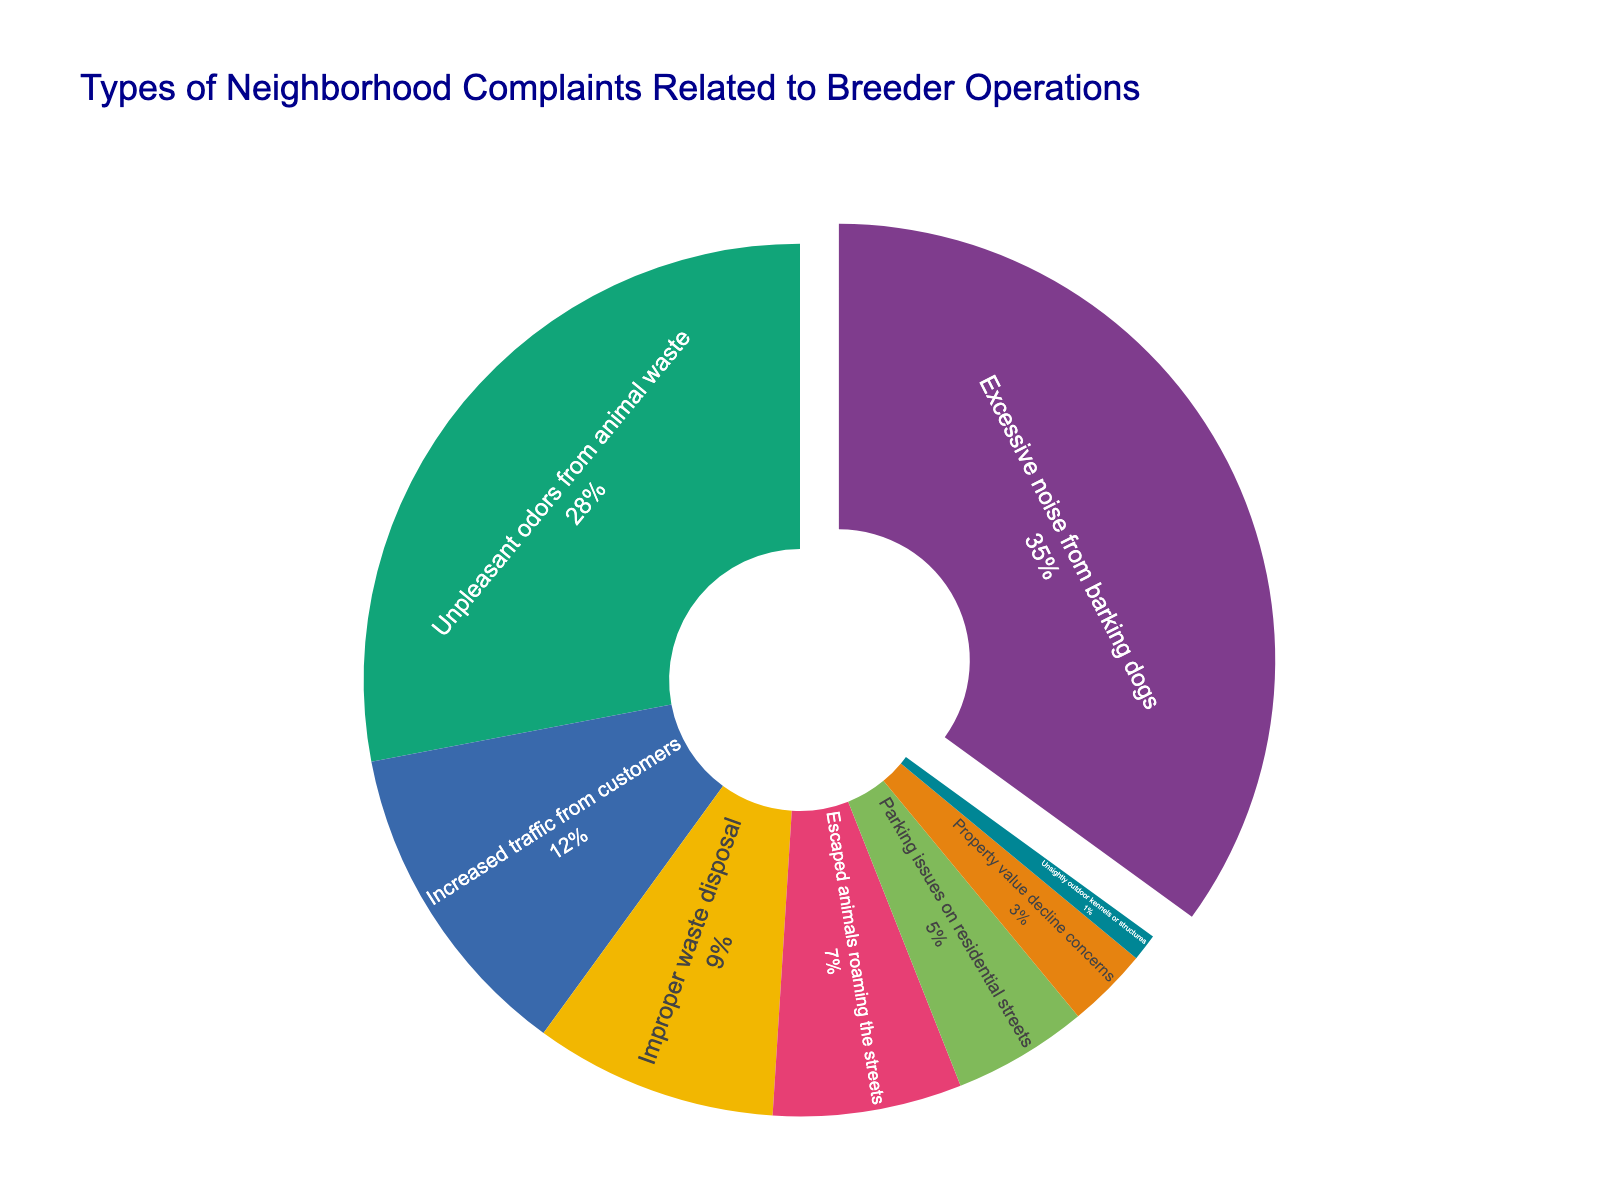What percentage of complaints are related to excessive noise from barking dogs? The figure states different types of complaints with associated percentages. For excessive noise from barking dogs, the percentage is clearly labeled as 35%.
Answer: 35% Which category has the second highest percentage of complaints? By examining the pie chart, the category with the highest percentage is excessive noise from barking dogs (35%), and the second highest is unpleasant odors from animal waste at 28%.
Answer: Unpleasant odors from animal waste What is the combined percentage of complaints related to improper waste disposal and parking issues on residential streets? Improper waste disposal accounts for 9% and parking issues on residential streets account for 5%. Adding these together gives 9% + 5% = 14%.
Answer: 14% How does the percentage of complaints about increased traffic from customers compare to those about escaped animals roaming the streets? The pie chart shows that increased traffic from customers accounts for 12%, while escaped animals roaming the streets account for 7%. Comparing these, 12% is greater than 7%.
Answer: Increased traffic from customers is greater What is the visual difference in the pie chart between excessive noise from barking dogs and other categories? The slice for excessive noise from barking dogs is slightly pulled out from the center of the pie, making it stand out visually from other categories.
Answer: Pulled out from the center Which category contributes the least to the complaints? Looking at the pie chart, the category with the smallest slice is unsightly outdoor kennels or structures at 1%.
Answer: Unsightly outdoor kennels or structures What is the combined percentage of complaints related to increased traffic from customers, escaped animals roaming the streets, and property value decline concerns? Adding the percentages for increased traffic from customers (12%), escaped animals roaming the streets (7%), and property value decline concerns (3%) yields 12% + 7% + 3% = 22%.
Answer: 22% How much higher is the percentage of complaints about unpleasant odors from animal waste compared to improper waste disposal? The percentage for unpleasant odors from animal waste is 28%, and for improper waste disposal, it is 9%. Subtracting these, 28% - 9% = 19%.
Answer: 19% Which two categories combined have a percentage closest to that of excessive noise from barking dogs? Looking at the percentages, increased traffic from customers (12%) and unpleasant odors from animal waste (28%) add up to 12% + 28% = 40%, which is closest to 35%.
Answer: Unpleasant odors from animal waste and increased traffic from customers 